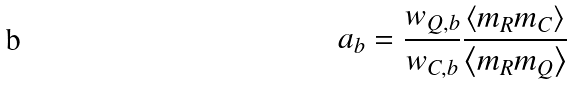<formula> <loc_0><loc_0><loc_500><loc_500>a _ { b } = \frac { w _ { Q , b } } { w _ { C , b } } \frac { \left \langle m _ { R } m _ { C } \right \rangle } { \left \langle m _ { R } m _ { Q } \right \rangle }</formula> 